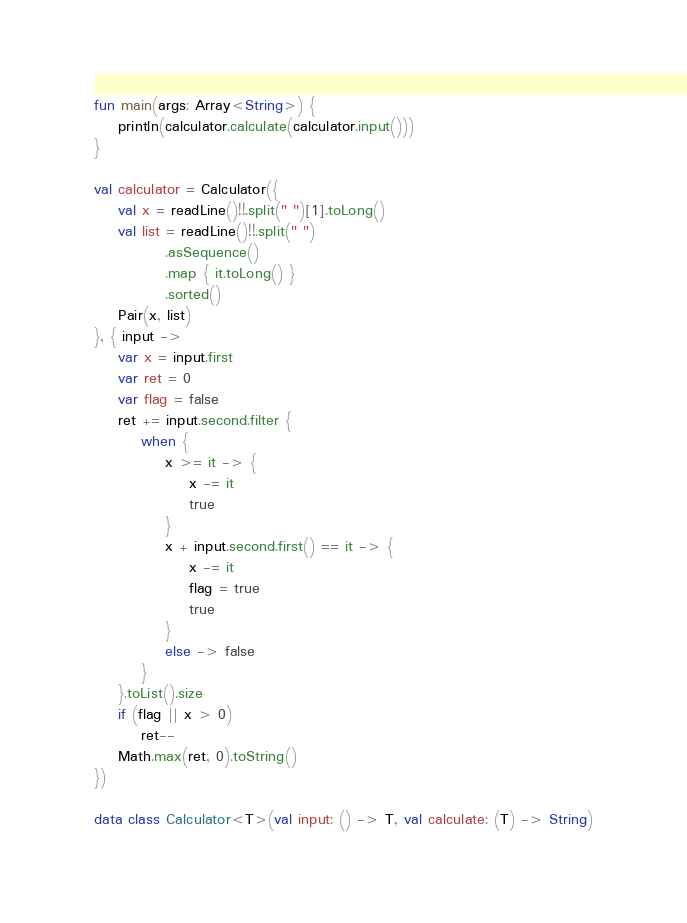Convert code to text. <code><loc_0><loc_0><loc_500><loc_500><_Kotlin_>fun main(args: Array<String>) {
    println(calculator.calculate(calculator.input()))
}

val calculator = Calculator({
    val x = readLine()!!.split(" ")[1].toLong()
    val list = readLine()!!.split(" ")
            .asSequence()
            .map { it.toLong() }
            .sorted()
    Pair(x, list)
}, { input ->
    var x = input.first
    var ret = 0
    var flag = false
    ret += input.second.filter {
        when {
            x >= it -> {
                x -= it
                true
            }
            x + input.second.first() == it -> {
                x -= it
                flag = true
                true
            }
            else -> false
        }
    }.toList().size
    if (flag || x > 0)
        ret--
    Math.max(ret, 0).toString()
})

data class Calculator<T>(val input: () -> T, val calculate: (T) -> String)
</code> 